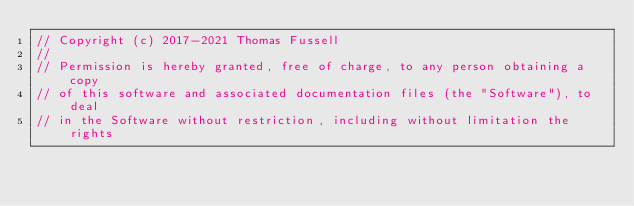Convert code to text. <code><loc_0><loc_0><loc_500><loc_500><_C++_>// Copyright (c) 2017-2021 Thomas Fussell
//
// Permission is hereby granted, free of charge, to any person obtaining a copy
// of this software and associated documentation files (the "Software"), to deal
// in the Software without restriction, including without limitation the rights</code> 